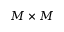<formula> <loc_0><loc_0><loc_500><loc_500>M \times M</formula> 